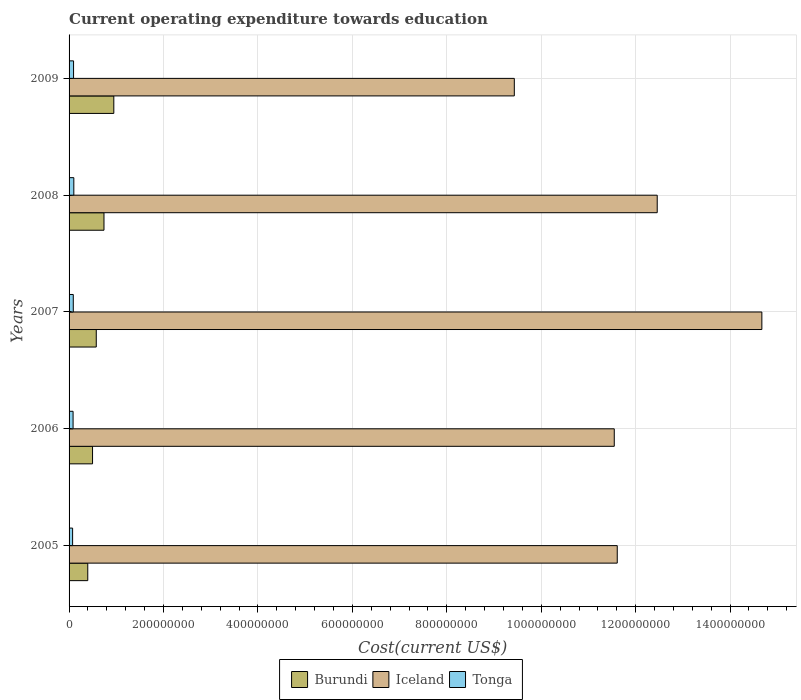How many different coloured bars are there?
Your answer should be compact. 3. How many groups of bars are there?
Give a very brief answer. 5. Are the number of bars per tick equal to the number of legend labels?
Provide a succinct answer. Yes. What is the label of the 2nd group of bars from the top?
Offer a very short reply. 2008. In how many cases, is the number of bars for a given year not equal to the number of legend labels?
Your answer should be very brief. 0. What is the expenditure towards education in Iceland in 2007?
Provide a short and direct response. 1.47e+09. Across all years, what is the maximum expenditure towards education in Tonga?
Make the answer very short. 1.01e+07. Across all years, what is the minimum expenditure towards education in Tonga?
Your answer should be very brief. 7.50e+06. What is the total expenditure towards education in Iceland in the graph?
Keep it short and to the point. 5.97e+09. What is the difference between the expenditure towards education in Burundi in 2007 and that in 2008?
Your response must be concise. -1.63e+07. What is the difference between the expenditure towards education in Tonga in 2008 and the expenditure towards education in Iceland in 2007?
Provide a succinct answer. -1.46e+09. What is the average expenditure towards education in Tonga per year?
Make the answer very short. 8.90e+06. In the year 2006, what is the difference between the expenditure towards education in Iceland and expenditure towards education in Burundi?
Make the answer very short. 1.10e+09. What is the ratio of the expenditure towards education in Burundi in 2006 to that in 2008?
Keep it short and to the point. 0.67. What is the difference between the highest and the second highest expenditure towards education in Tonga?
Provide a short and direct response. 5.66e+05. What is the difference between the highest and the lowest expenditure towards education in Iceland?
Provide a short and direct response. 5.24e+08. In how many years, is the expenditure towards education in Tonga greater than the average expenditure towards education in Tonga taken over all years?
Your answer should be very brief. 3. Is the sum of the expenditure towards education in Burundi in 2005 and 2006 greater than the maximum expenditure towards education in Tonga across all years?
Give a very brief answer. Yes. What does the 1st bar from the bottom in 2007 represents?
Offer a very short reply. Burundi. Is it the case that in every year, the sum of the expenditure towards education in Iceland and expenditure towards education in Tonga is greater than the expenditure towards education in Burundi?
Your response must be concise. Yes. Are all the bars in the graph horizontal?
Give a very brief answer. Yes. How many years are there in the graph?
Provide a short and direct response. 5. What is the difference between two consecutive major ticks on the X-axis?
Offer a terse response. 2.00e+08. Where does the legend appear in the graph?
Your answer should be very brief. Bottom center. What is the title of the graph?
Keep it short and to the point. Current operating expenditure towards education. Does "Niger" appear as one of the legend labels in the graph?
Provide a succinct answer. No. What is the label or title of the X-axis?
Your answer should be compact. Cost(current US$). What is the label or title of the Y-axis?
Make the answer very short. Years. What is the Cost(current US$) in Burundi in 2005?
Your response must be concise. 3.96e+07. What is the Cost(current US$) in Iceland in 2005?
Make the answer very short. 1.16e+09. What is the Cost(current US$) of Tonga in 2005?
Ensure brevity in your answer.  7.50e+06. What is the Cost(current US$) of Burundi in 2006?
Your answer should be compact. 4.97e+07. What is the Cost(current US$) in Iceland in 2006?
Give a very brief answer. 1.15e+09. What is the Cost(current US$) in Tonga in 2006?
Ensure brevity in your answer.  8.50e+06. What is the Cost(current US$) in Burundi in 2007?
Keep it short and to the point. 5.76e+07. What is the Cost(current US$) of Iceland in 2007?
Keep it short and to the point. 1.47e+09. What is the Cost(current US$) of Tonga in 2007?
Offer a terse response. 8.90e+06. What is the Cost(current US$) in Burundi in 2008?
Make the answer very short. 7.39e+07. What is the Cost(current US$) in Iceland in 2008?
Keep it short and to the point. 1.25e+09. What is the Cost(current US$) of Tonga in 2008?
Offer a very short reply. 1.01e+07. What is the Cost(current US$) of Burundi in 2009?
Ensure brevity in your answer.  9.48e+07. What is the Cost(current US$) in Iceland in 2009?
Make the answer very short. 9.43e+08. What is the Cost(current US$) of Tonga in 2009?
Make the answer very short. 9.51e+06. Across all years, what is the maximum Cost(current US$) in Burundi?
Your response must be concise. 9.48e+07. Across all years, what is the maximum Cost(current US$) of Iceland?
Make the answer very short. 1.47e+09. Across all years, what is the maximum Cost(current US$) of Tonga?
Your response must be concise. 1.01e+07. Across all years, what is the minimum Cost(current US$) in Burundi?
Offer a very short reply. 3.96e+07. Across all years, what is the minimum Cost(current US$) in Iceland?
Make the answer very short. 9.43e+08. Across all years, what is the minimum Cost(current US$) in Tonga?
Provide a short and direct response. 7.50e+06. What is the total Cost(current US$) of Burundi in the graph?
Offer a terse response. 3.16e+08. What is the total Cost(current US$) in Iceland in the graph?
Your answer should be very brief. 5.97e+09. What is the total Cost(current US$) in Tonga in the graph?
Offer a very short reply. 4.45e+07. What is the difference between the Cost(current US$) of Burundi in 2005 and that in 2006?
Make the answer very short. -1.01e+07. What is the difference between the Cost(current US$) of Iceland in 2005 and that in 2006?
Your response must be concise. 6.32e+06. What is the difference between the Cost(current US$) in Tonga in 2005 and that in 2006?
Your response must be concise. -1.00e+06. What is the difference between the Cost(current US$) of Burundi in 2005 and that in 2007?
Your answer should be very brief. -1.80e+07. What is the difference between the Cost(current US$) of Iceland in 2005 and that in 2007?
Offer a very short reply. -3.06e+08. What is the difference between the Cost(current US$) in Tonga in 2005 and that in 2007?
Give a very brief answer. -1.40e+06. What is the difference between the Cost(current US$) in Burundi in 2005 and that in 2008?
Keep it short and to the point. -3.44e+07. What is the difference between the Cost(current US$) in Iceland in 2005 and that in 2008?
Ensure brevity in your answer.  -8.47e+07. What is the difference between the Cost(current US$) in Tonga in 2005 and that in 2008?
Make the answer very short. -2.57e+06. What is the difference between the Cost(current US$) in Burundi in 2005 and that in 2009?
Offer a very short reply. -5.52e+07. What is the difference between the Cost(current US$) in Iceland in 2005 and that in 2009?
Provide a short and direct response. 2.18e+08. What is the difference between the Cost(current US$) in Tonga in 2005 and that in 2009?
Give a very brief answer. -2.01e+06. What is the difference between the Cost(current US$) in Burundi in 2006 and that in 2007?
Keep it short and to the point. -7.88e+06. What is the difference between the Cost(current US$) in Iceland in 2006 and that in 2007?
Offer a terse response. -3.13e+08. What is the difference between the Cost(current US$) in Tonga in 2006 and that in 2007?
Offer a terse response. -4.01e+05. What is the difference between the Cost(current US$) of Burundi in 2006 and that in 2008?
Ensure brevity in your answer.  -2.42e+07. What is the difference between the Cost(current US$) of Iceland in 2006 and that in 2008?
Provide a short and direct response. -9.10e+07. What is the difference between the Cost(current US$) in Tonga in 2006 and that in 2008?
Offer a terse response. -1.57e+06. What is the difference between the Cost(current US$) in Burundi in 2006 and that in 2009?
Give a very brief answer. -4.50e+07. What is the difference between the Cost(current US$) of Iceland in 2006 and that in 2009?
Your answer should be very brief. 2.12e+08. What is the difference between the Cost(current US$) of Tonga in 2006 and that in 2009?
Your response must be concise. -1.01e+06. What is the difference between the Cost(current US$) of Burundi in 2007 and that in 2008?
Ensure brevity in your answer.  -1.63e+07. What is the difference between the Cost(current US$) of Iceland in 2007 and that in 2008?
Ensure brevity in your answer.  2.22e+08. What is the difference between the Cost(current US$) of Tonga in 2007 and that in 2008?
Your answer should be very brief. -1.17e+06. What is the difference between the Cost(current US$) of Burundi in 2007 and that in 2009?
Offer a terse response. -3.71e+07. What is the difference between the Cost(current US$) in Iceland in 2007 and that in 2009?
Offer a terse response. 5.24e+08. What is the difference between the Cost(current US$) of Tonga in 2007 and that in 2009?
Give a very brief answer. -6.07e+05. What is the difference between the Cost(current US$) of Burundi in 2008 and that in 2009?
Give a very brief answer. -2.08e+07. What is the difference between the Cost(current US$) of Iceland in 2008 and that in 2009?
Give a very brief answer. 3.03e+08. What is the difference between the Cost(current US$) of Tonga in 2008 and that in 2009?
Offer a terse response. 5.66e+05. What is the difference between the Cost(current US$) of Burundi in 2005 and the Cost(current US$) of Iceland in 2006?
Keep it short and to the point. -1.12e+09. What is the difference between the Cost(current US$) of Burundi in 2005 and the Cost(current US$) of Tonga in 2006?
Offer a terse response. 3.11e+07. What is the difference between the Cost(current US$) in Iceland in 2005 and the Cost(current US$) in Tonga in 2006?
Make the answer very short. 1.15e+09. What is the difference between the Cost(current US$) of Burundi in 2005 and the Cost(current US$) of Iceland in 2007?
Offer a very short reply. -1.43e+09. What is the difference between the Cost(current US$) of Burundi in 2005 and the Cost(current US$) of Tonga in 2007?
Keep it short and to the point. 3.07e+07. What is the difference between the Cost(current US$) of Iceland in 2005 and the Cost(current US$) of Tonga in 2007?
Provide a short and direct response. 1.15e+09. What is the difference between the Cost(current US$) of Burundi in 2005 and the Cost(current US$) of Iceland in 2008?
Give a very brief answer. -1.21e+09. What is the difference between the Cost(current US$) of Burundi in 2005 and the Cost(current US$) of Tonga in 2008?
Ensure brevity in your answer.  2.95e+07. What is the difference between the Cost(current US$) of Iceland in 2005 and the Cost(current US$) of Tonga in 2008?
Make the answer very short. 1.15e+09. What is the difference between the Cost(current US$) in Burundi in 2005 and the Cost(current US$) in Iceland in 2009?
Provide a short and direct response. -9.03e+08. What is the difference between the Cost(current US$) in Burundi in 2005 and the Cost(current US$) in Tonga in 2009?
Offer a terse response. 3.01e+07. What is the difference between the Cost(current US$) of Iceland in 2005 and the Cost(current US$) of Tonga in 2009?
Make the answer very short. 1.15e+09. What is the difference between the Cost(current US$) in Burundi in 2006 and the Cost(current US$) in Iceland in 2007?
Your answer should be very brief. -1.42e+09. What is the difference between the Cost(current US$) in Burundi in 2006 and the Cost(current US$) in Tonga in 2007?
Provide a short and direct response. 4.08e+07. What is the difference between the Cost(current US$) of Iceland in 2006 and the Cost(current US$) of Tonga in 2007?
Offer a terse response. 1.15e+09. What is the difference between the Cost(current US$) in Burundi in 2006 and the Cost(current US$) in Iceland in 2008?
Keep it short and to the point. -1.20e+09. What is the difference between the Cost(current US$) of Burundi in 2006 and the Cost(current US$) of Tonga in 2008?
Offer a terse response. 3.97e+07. What is the difference between the Cost(current US$) of Iceland in 2006 and the Cost(current US$) of Tonga in 2008?
Your response must be concise. 1.14e+09. What is the difference between the Cost(current US$) of Burundi in 2006 and the Cost(current US$) of Iceland in 2009?
Offer a terse response. -8.93e+08. What is the difference between the Cost(current US$) in Burundi in 2006 and the Cost(current US$) in Tonga in 2009?
Keep it short and to the point. 4.02e+07. What is the difference between the Cost(current US$) in Iceland in 2006 and the Cost(current US$) in Tonga in 2009?
Ensure brevity in your answer.  1.15e+09. What is the difference between the Cost(current US$) of Burundi in 2007 and the Cost(current US$) of Iceland in 2008?
Provide a short and direct response. -1.19e+09. What is the difference between the Cost(current US$) in Burundi in 2007 and the Cost(current US$) in Tonga in 2008?
Ensure brevity in your answer.  4.75e+07. What is the difference between the Cost(current US$) in Iceland in 2007 and the Cost(current US$) in Tonga in 2008?
Your answer should be compact. 1.46e+09. What is the difference between the Cost(current US$) in Burundi in 2007 and the Cost(current US$) in Iceland in 2009?
Make the answer very short. -8.85e+08. What is the difference between the Cost(current US$) in Burundi in 2007 and the Cost(current US$) in Tonga in 2009?
Provide a short and direct response. 4.81e+07. What is the difference between the Cost(current US$) in Iceland in 2007 and the Cost(current US$) in Tonga in 2009?
Provide a short and direct response. 1.46e+09. What is the difference between the Cost(current US$) in Burundi in 2008 and the Cost(current US$) in Iceland in 2009?
Your answer should be very brief. -8.69e+08. What is the difference between the Cost(current US$) of Burundi in 2008 and the Cost(current US$) of Tonga in 2009?
Make the answer very short. 6.44e+07. What is the difference between the Cost(current US$) in Iceland in 2008 and the Cost(current US$) in Tonga in 2009?
Ensure brevity in your answer.  1.24e+09. What is the average Cost(current US$) of Burundi per year?
Your answer should be very brief. 6.31e+07. What is the average Cost(current US$) of Iceland per year?
Your answer should be compact. 1.19e+09. What is the average Cost(current US$) of Tonga per year?
Provide a succinct answer. 8.90e+06. In the year 2005, what is the difference between the Cost(current US$) of Burundi and Cost(current US$) of Iceland?
Make the answer very short. -1.12e+09. In the year 2005, what is the difference between the Cost(current US$) in Burundi and Cost(current US$) in Tonga?
Provide a short and direct response. 3.21e+07. In the year 2005, what is the difference between the Cost(current US$) of Iceland and Cost(current US$) of Tonga?
Provide a short and direct response. 1.15e+09. In the year 2006, what is the difference between the Cost(current US$) of Burundi and Cost(current US$) of Iceland?
Ensure brevity in your answer.  -1.10e+09. In the year 2006, what is the difference between the Cost(current US$) of Burundi and Cost(current US$) of Tonga?
Offer a terse response. 4.12e+07. In the year 2006, what is the difference between the Cost(current US$) in Iceland and Cost(current US$) in Tonga?
Keep it short and to the point. 1.15e+09. In the year 2007, what is the difference between the Cost(current US$) in Burundi and Cost(current US$) in Iceland?
Provide a short and direct response. -1.41e+09. In the year 2007, what is the difference between the Cost(current US$) in Burundi and Cost(current US$) in Tonga?
Provide a short and direct response. 4.87e+07. In the year 2007, what is the difference between the Cost(current US$) in Iceland and Cost(current US$) in Tonga?
Your response must be concise. 1.46e+09. In the year 2008, what is the difference between the Cost(current US$) in Burundi and Cost(current US$) in Iceland?
Your response must be concise. -1.17e+09. In the year 2008, what is the difference between the Cost(current US$) in Burundi and Cost(current US$) in Tonga?
Provide a succinct answer. 6.39e+07. In the year 2008, what is the difference between the Cost(current US$) of Iceland and Cost(current US$) of Tonga?
Offer a terse response. 1.24e+09. In the year 2009, what is the difference between the Cost(current US$) in Burundi and Cost(current US$) in Iceland?
Provide a succinct answer. -8.48e+08. In the year 2009, what is the difference between the Cost(current US$) of Burundi and Cost(current US$) of Tonga?
Your answer should be compact. 8.52e+07. In the year 2009, what is the difference between the Cost(current US$) in Iceland and Cost(current US$) in Tonga?
Provide a succinct answer. 9.34e+08. What is the ratio of the Cost(current US$) of Burundi in 2005 to that in 2006?
Your answer should be compact. 0.8. What is the ratio of the Cost(current US$) of Iceland in 2005 to that in 2006?
Give a very brief answer. 1.01. What is the ratio of the Cost(current US$) of Tonga in 2005 to that in 2006?
Provide a short and direct response. 0.88. What is the ratio of the Cost(current US$) of Burundi in 2005 to that in 2007?
Provide a succinct answer. 0.69. What is the ratio of the Cost(current US$) of Iceland in 2005 to that in 2007?
Give a very brief answer. 0.79. What is the ratio of the Cost(current US$) of Tonga in 2005 to that in 2007?
Provide a short and direct response. 0.84. What is the ratio of the Cost(current US$) of Burundi in 2005 to that in 2008?
Your answer should be very brief. 0.54. What is the ratio of the Cost(current US$) in Iceland in 2005 to that in 2008?
Your answer should be very brief. 0.93. What is the ratio of the Cost(current US$) of Tonga in 2005 to that in 2008?
Give a very brief answer. 0.74. What is the ratio of the Cost(current US$) of Burundi in 2005 to that in 2009?
Make the answer very short. 0.42. What is the ratio of the Cost(current US$) of Iceland in 2005 to that in 2009?
Provide a short and direct response. 1.23. What is the ratio of the Cost(current US$) in Tonga in 2005 to that in 2009?
Provide a succinct answer. 0.79. What is the ratio of the Cost(current US$) of Burundi in 2006 to that in 2007?
Offer a terse response. 0.86. What is the ratio of the Cost(current US$) of Iceland in 2006 to that in 2007?
Provide a succinct answer. 0.79. What is the ratio of the Cost(current US$) in Tonga in 2006 to that in 2007?
Your answer should be compact. 0.95. What is the ratio of the Cost(current US$) in Burundi in 2006 to that in 2008?
Your answer should be very brief. 0.67. What is the ratio of the Cost(current US$) in Iceland in 2006 to that in 2008?
Provide a short and direct response. 0.93. What is the ratio of the Cost(current US$) in Tonga in 2006 to that in 2008?
Provide a short and direct response. 0.84. What is the ratio of the Cost(current US$) in Burundi in 2006 to that in 2009?
Your answer should be very brief. 0.52. What is the ratio of the Cost(current US$) in Iceland in 2006 to that in 2009?
Make the answer very short. 1.22. What is the ratio of the Cost(current US$) in Tonga in 2006 to that in 2009?
Your response must be concise. 0.89. What is the ratio of the Cost(current US$) in Burundi in 2007 to that in 2008?
Keep it short and to the point. 0.78. What is the ratio of the Cost(current US$) in Iceland in 2007 to that in 2008?
Keep it short and to the point. 1.18. What is the ratio of the Cost(current US$) in Tonga in 2007 to that in 2008?
Your answer should be compact. 0.88. What is the ratio of the Cost(current US$) of Burundi in 2007 to that in 2009?
Keep it short and to the point. 0.61. What is the ratio of the Cost(current US$) in Iceland in 2007 to that in 2009?
Your answer should be very brief. 1.56. What is the ratio of the Cost(current US$) of Tonga in 2007 to that in 2009?
Provide a short and direct response. 0.94. What is the ratio of the Cost(current US$) of Burundi in 2008 to that in 2009?
Offer a terse response. 0.78. What is the ratio of the Cost(current US$) in Iceland in 2008 to that in 2009?
Provide a short and direct response. 1.32. What is the ratio of the Cost(current US$) of Tonga in 2008 to that in 2009?
Your answer should be very brief. 1.06. What is the difference between the highest and the second highest Cost(current US$) in Burundi?
Make the answer very short. 2.08e+07. What is the difference between the highest and the second highest Cost(current US$) of Iceland?
Provide a short and direct response. 2.22e+08. What is the difference between the highest and the second highest Cost(current US$) in Tonga?
Offer a very short reply. 5.66e+05. What is the difference between the highest and the lowest Cost(current US$) in Burundi?
Provide a short and direct response. 5.52e+07. What is the difference between the highest and the lowest Cost(current US$) in Iceland?
Keep it short and to the point. 5.24e+08. What is the difference between the highest and the lowest Cost(current US$) of Tonga?
Offer a very short reply. 2.57e+06. 